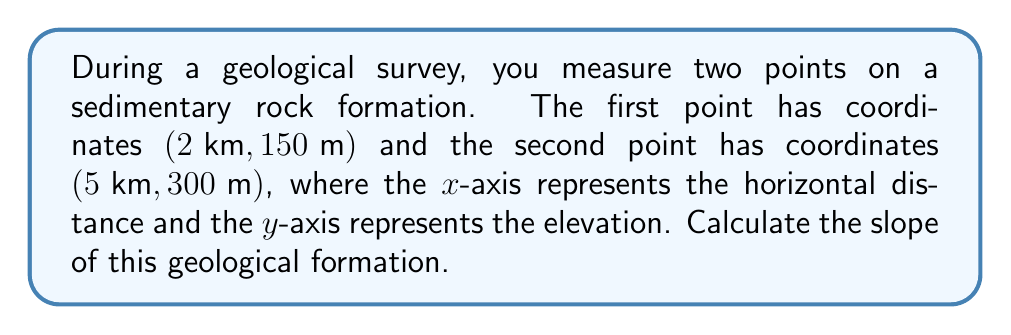Provide a solution to this math problem. To determine the slope of the geological formation, we need to use the slope formula:

$$ \text{Slope} = \frac{\text{Change in y}}{\text{Change in x}} = \frac{y_2 - y_1}{x_2 - x_1} $$

Let's identify our points:
$(x_1, y_1) = (2 \text{ km}, 150 \text{ m})$
$(x_2, y_2) = (5 \text{ km}, 300 \text{ m})$

Step 1: Calculate the change in y (elevation):
$\Delta y = y_2 - y_1 = 300 \text{ m} - 150 \text{ m} = 150 \text{ m}$

Step 2: Calculate the change in x (horizontal distance):
$\Delta x = x_2 - x_1 = 5 \text{ km} - 2 \text{ km} = 3 \text{ km}$

Step 3: Convert km to m for consistency:
$3 \text{ km} = 3000 \text{ m}$

Step 4: Apply the slope formula:
$$ \text{Slope} = \frac{150 \text{ m}}{3000 \text{ m}} = 0.05 $$

Step 5: Convert to a percentage:
$0.05 \times 100\% = 5\%$

Therefore, the slope of the geological formation is 0.05 or 5%.
Answer: 0.05 or 5% 